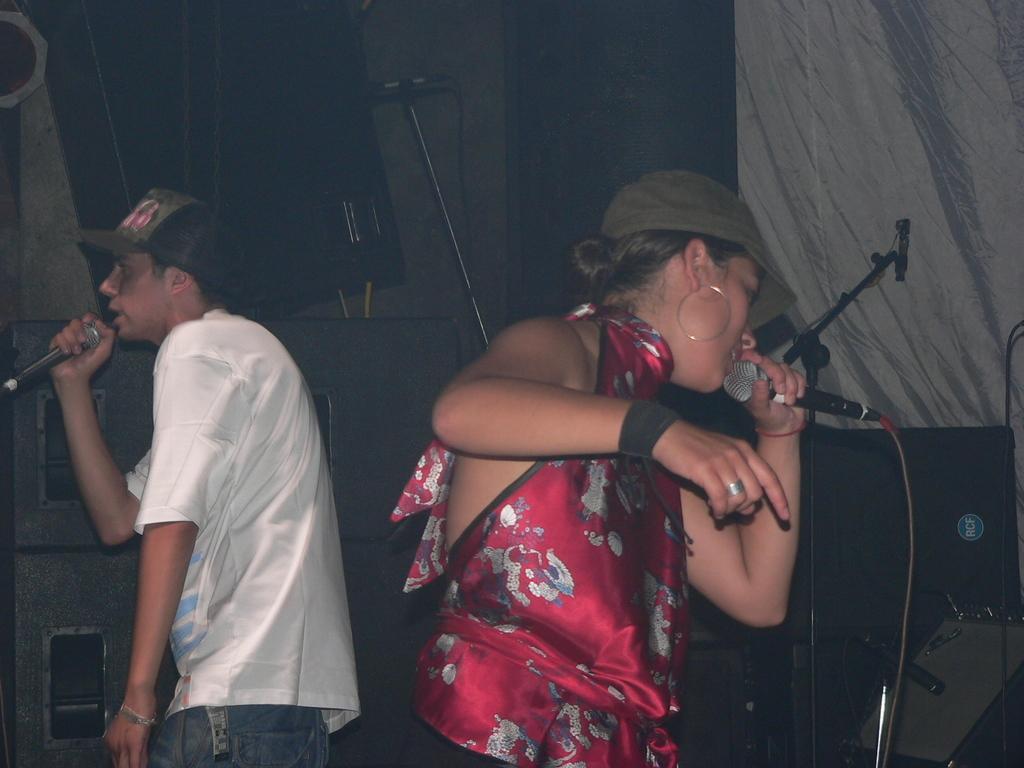Could you give a brief overview of what you see in this image? This picture shows a man and woman singing with the help of a microphone on the dais. 